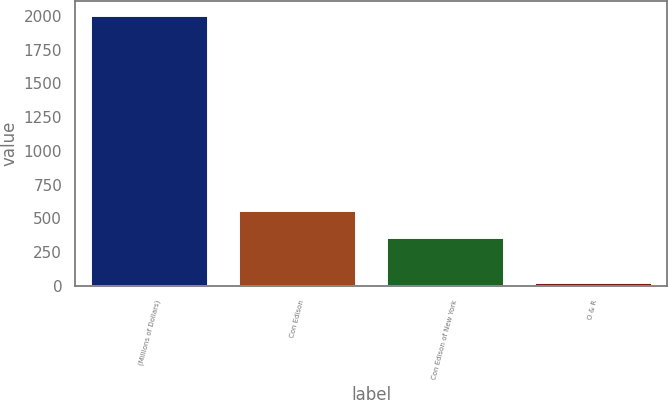Convert chart to OTSL. <chart><loc_0><loc_0><loc_500><loc_500><bar_chart><fcel>(Millions of Dollars)<fcel>Con Edison<fcel>Con Edison of New York<fcel>O & R<nl><fcel>2007<fcel>560<fcel>362<fcel>27<nl></chart> 